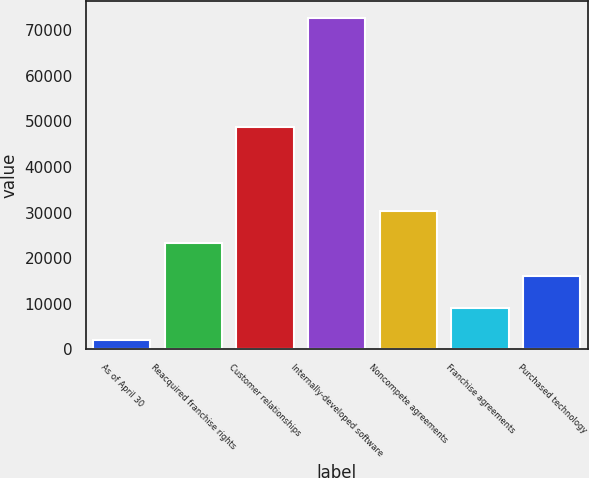Convert chart. <chart><loc_0><loc_0><loc_500><loc_500><bar_chart><fcel>As of April 30<fcel>Reacquired franchise rights<fcel>Customer relationships<fcel>Internally-developed software<fcel>Noncompete agreements<fcel>Franchise agreements<fcel>Purchased technology<nl><fcel>2013<fcel>23238.3<fcel>48733<fcel>72764<fcel>30313.4<fcel>9088.1<fcel>16163.2<nl></chart> 